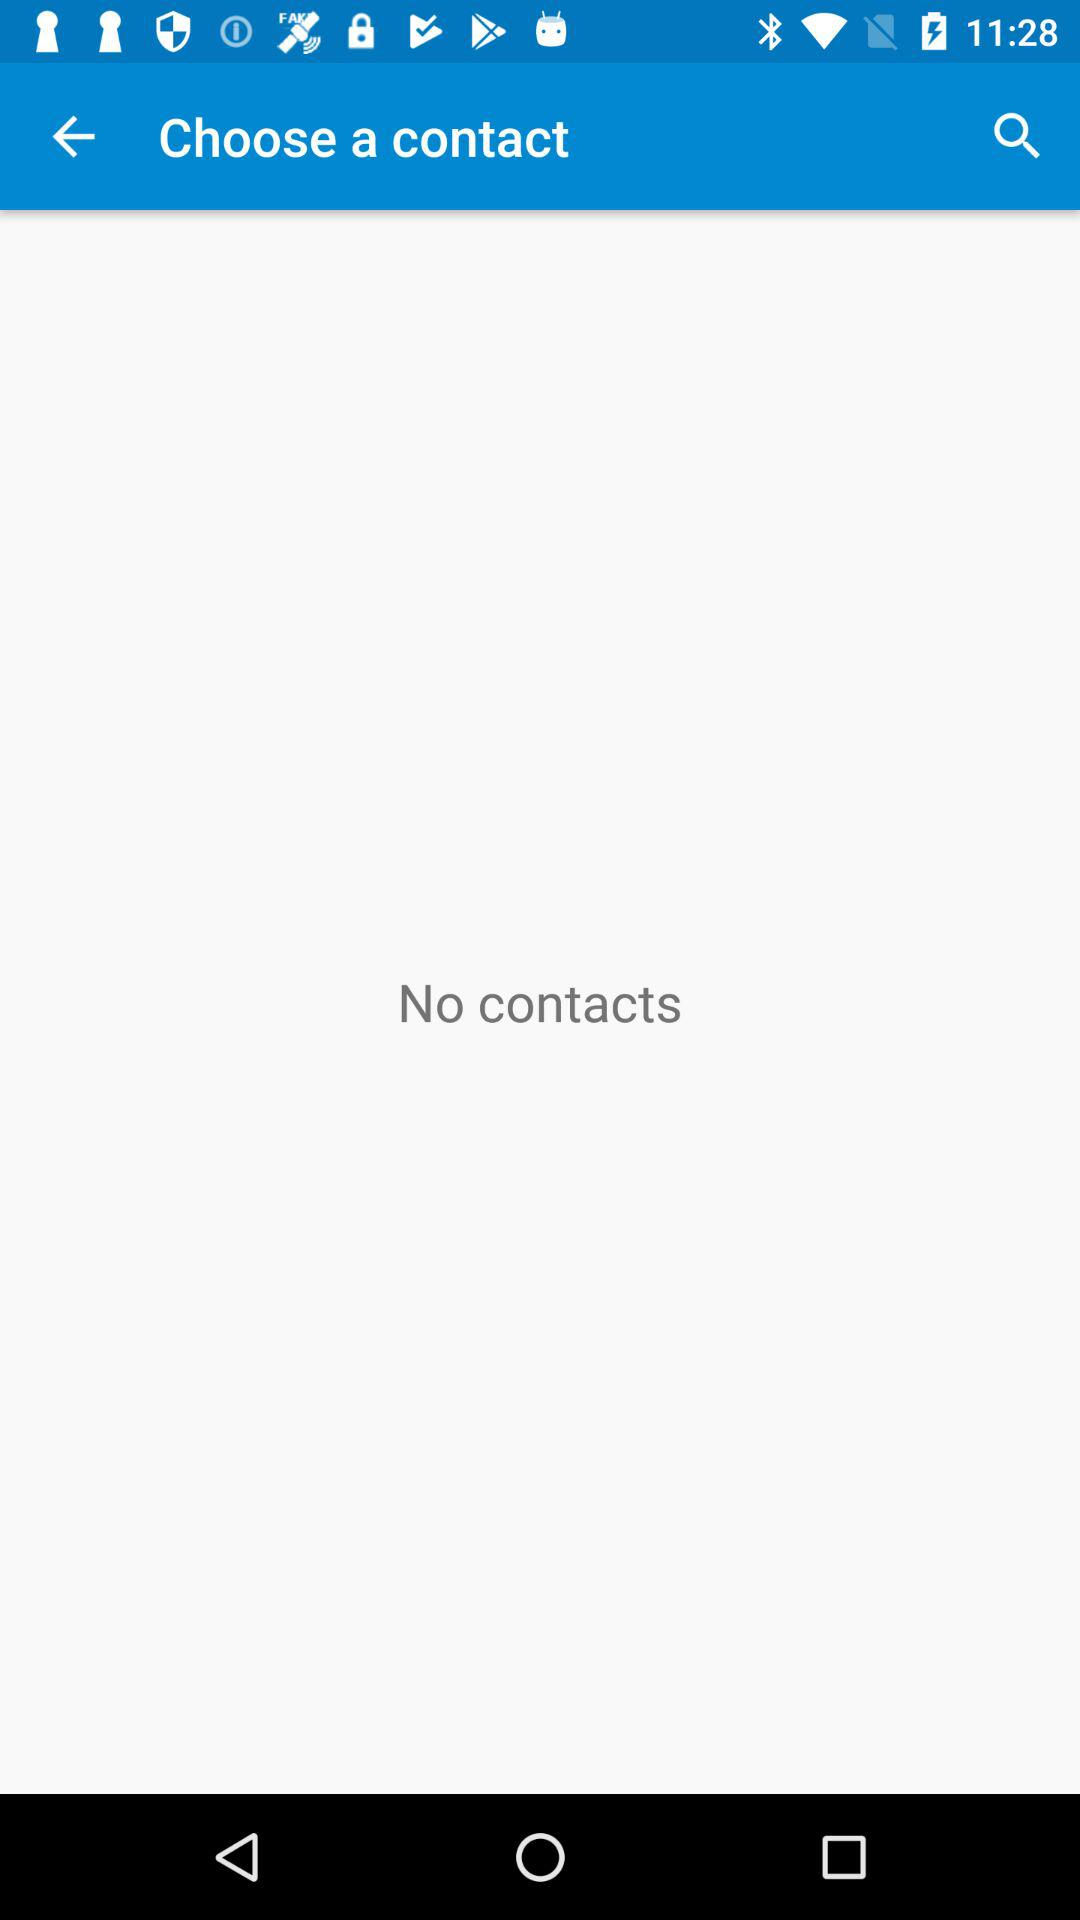Is there any contact? There are no contacts. 